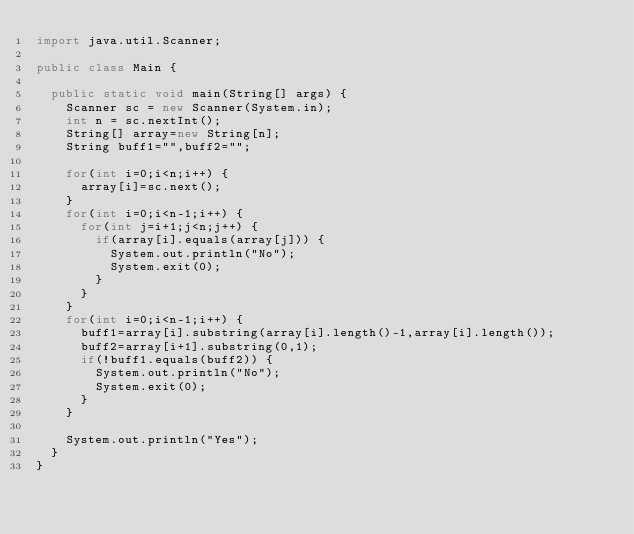<code> <loc_0><loc_0><loc_500><loc_500><_Java_>import java.util.Scanner;

public class Main {

	public static void main(String[] args) {
		Scanner sc = new Scanner(System.in);
		int n = sc.nextInt();
		String[] array=new String[n];
		String buff1="",buff2="";

		for(int i=0;i<n;i++) {
			array[i]=sc.next();
		}
		for(int i=0;i<n-1;i++) {
			for(int j=i+1;j<n;j++) {
				if(array[i].equals(array[j])) {
					System.out.println("No");
					System.exit(0);
				}
			}
		}
		for(int i=0;i<n-1;i++) {
			buff1=array[i].substring(array[i].length()-1,array[i].length());
			buff2=array[i+1].substring(0,1);
			if(!buff1.equals(buff2)) {
				System.out.println("No");
				System.exit(0);
			}
		}

		System.out.println("Yes");
	}
}


</code> 